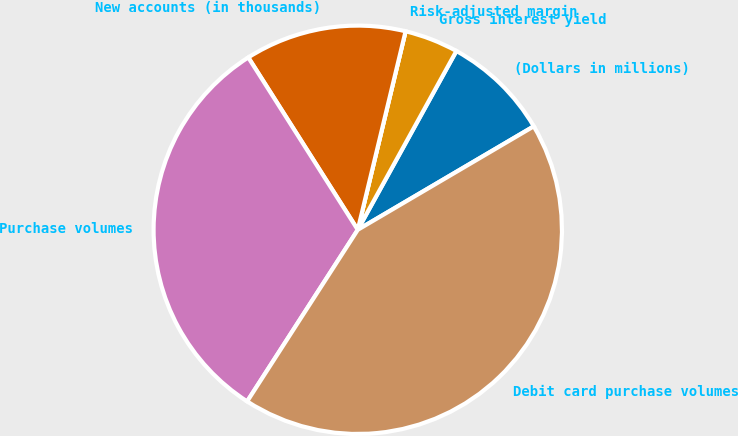Convert chart. <chart><loc_0><loc_0><loc_500><loc_500><pie_chart><fcel>(Dollars in millions)<fcel>Gross interest yield<fcel>Risk-adjusted margin<fcel>New accounts (in thousands)<fcel>Purchase volumes<fcel>Debit card purchase volumes<nl><fcel>8.52%<fcel>4.26%<fcel>0.0%<fcel>12.77%<fcel>31.88%<fcel>42.57%<nl></chart> 